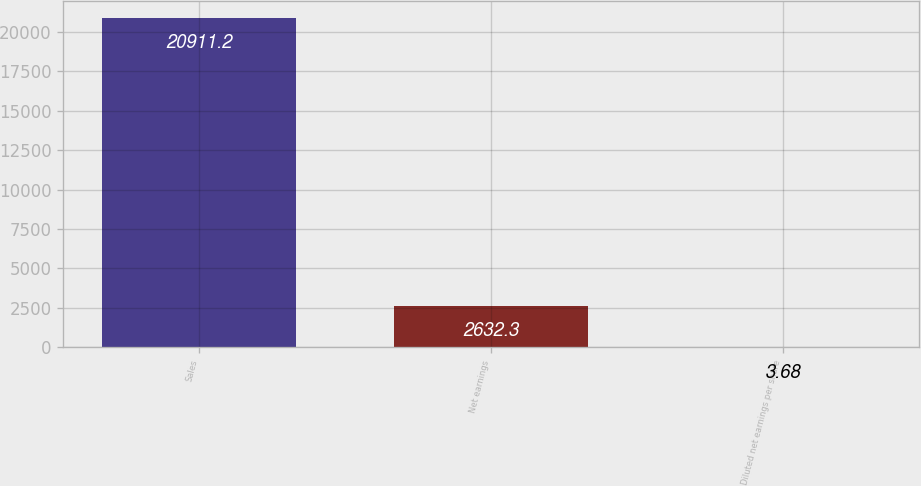Convert chart. <chart><loc_0><loc_0><loc_500><loc_500><bar_chart><fcel>Sales<fcel>Net earnings<fcel>Diluted net earnings per share<nl><fcel>20911.2<fcel>2632.3<fcel>3.68<nl></chart> 